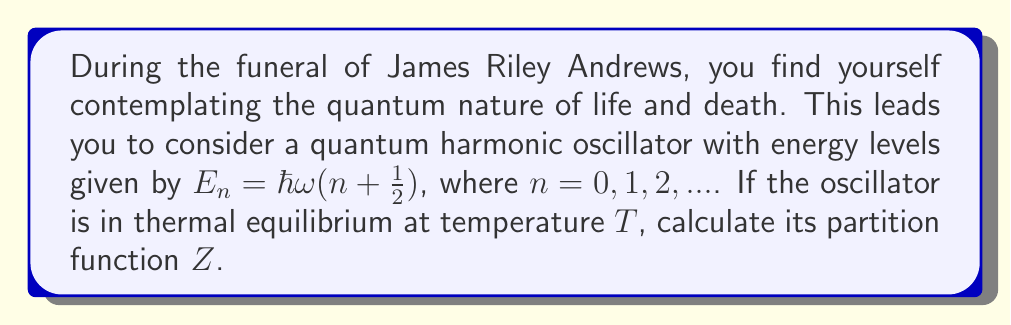What is the answer to this math problem? To solve this problem, we'll follow these steps:

1) The partition function $Z$ is defined as the sum over all possible states:

   $$Z = \sum_{n=0}^{\infty} e^{-\beta E_n}$$

   where $\beta = \frac{1}{k_B T}$, $k_B$ is Boltzmann's constant, and $T$ is temperature.

2) Substitute the energy levels $E_n = \hbar\omega(n + \frac{1}{2})$ into the partition function:

   $$Z = \sum_{n=0}^{\infty} e^{-\beta \hbar\omega(n + \frac{1}{2})}$$

3) Factor out the constant term:

   $$Z = e^{-\beta \hbar\omega/2} \sum_{n=0}^{\infty} e^{-\beta \hbar\omega n}$$

4) Let $x = e^{-\beta \hbar\omega}$. Then the sum becomes a geometric series:

   $$Z = e^{-\beta \hbar\omega/2} \sum_{n=0}^{\infty} x^n$$

5) The sum of an infinite geometric series with $|x| < 1$ is given by $\frac{1}{1-x}$. Here, $|x| < 1$ is always true for positive $T$. Therefore:

   $$Z = e^{-\beta \hbar\omega/2} \frac{1}{1-e^{-\beta \hbar\omega}}$$

6) This can be rewritten as:

   $$Z = \frac{e^{-\beta \hbar\omega/2}}{1-e^{-\beta \hbar\omega}}$$

This is the partition function for a quantum harmonic oscillator.
Answer: $$Z = \frac{e^{-\beta \hbar\omega/2}}{1-e^{-\beta \hbar\omega}}$$ 